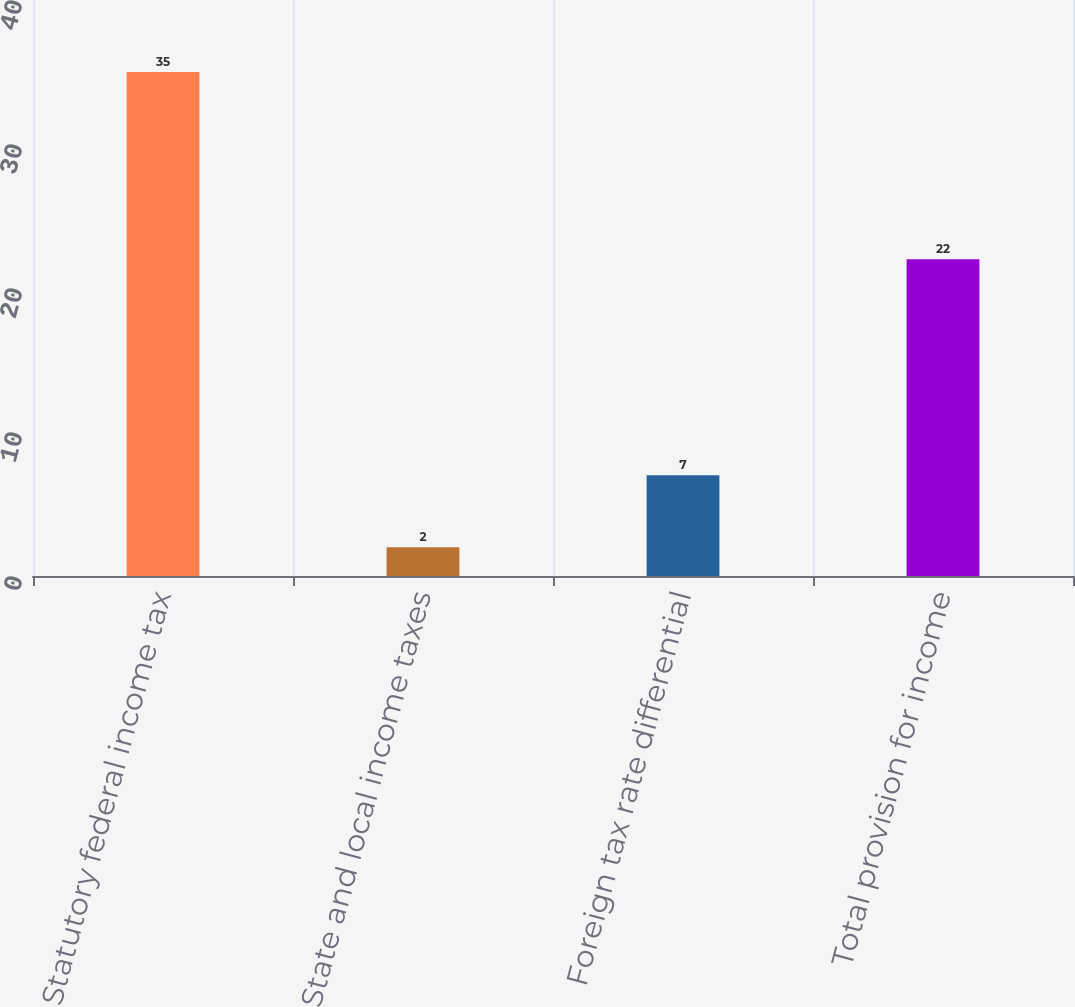<chart> <loc_0><loc_0><loc_500><loc_500><bar_chart><fcel>Statutory federal income tax<fcel>State and local income taxes<fcel>Foreign tax rate differential<fcel>Total provision for income<nl><fcel>35<fcel>2<fcel>7<fcel>22<nl></chart> 